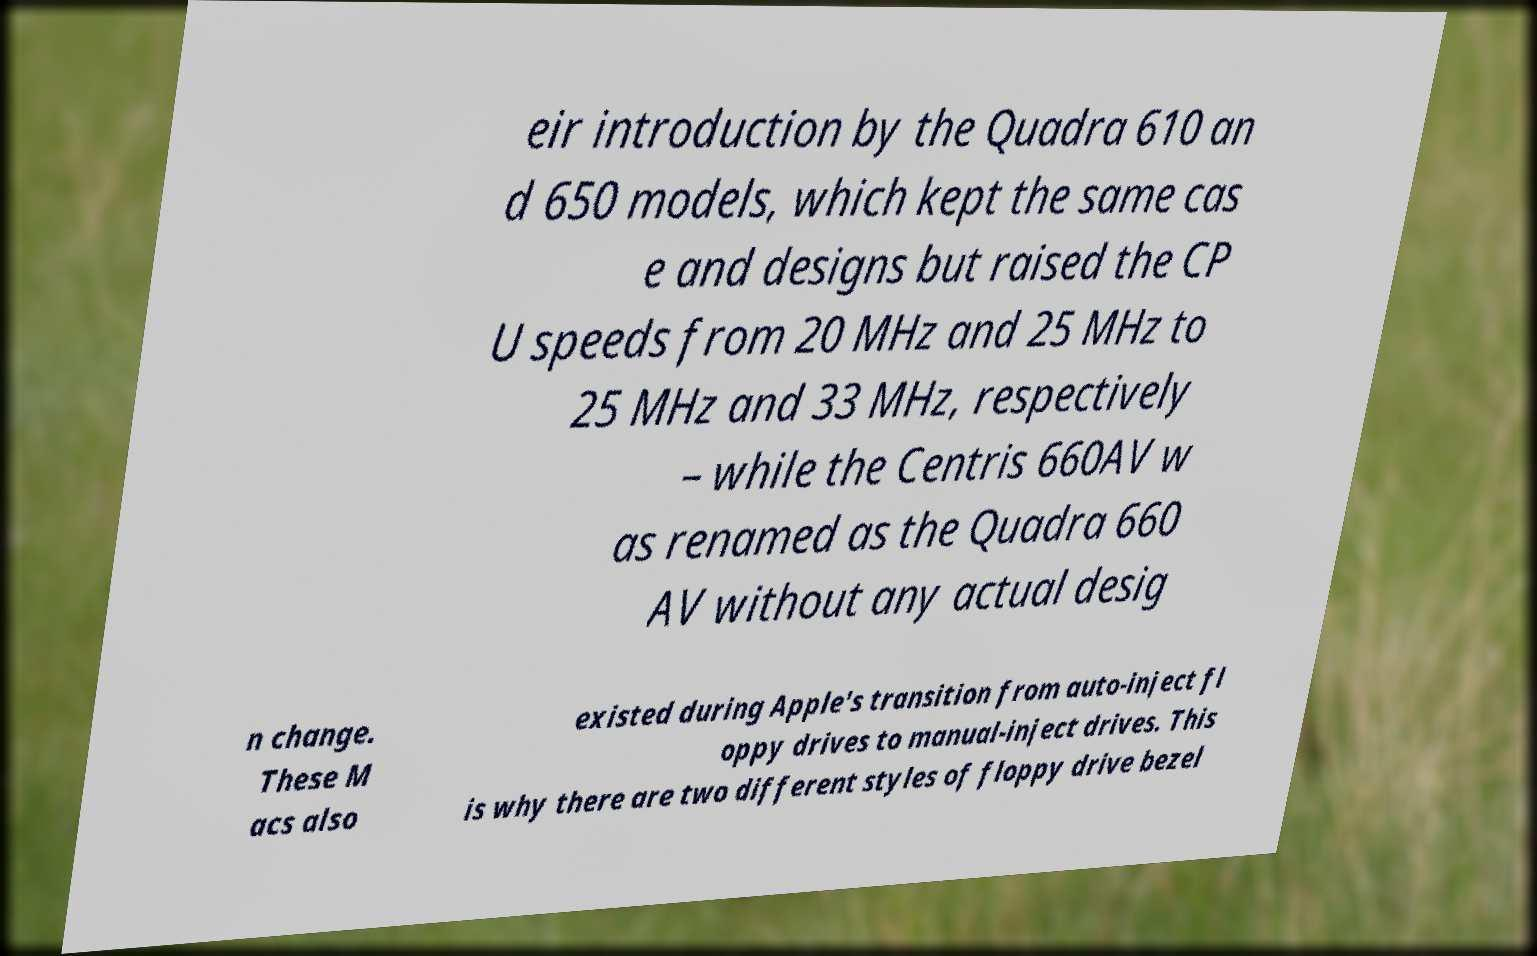What messages or text are displayed in this image? I need them in a readable, typed format. eir introduction by the Quadra 610 an d 650 models, which kept the same cas e and designs but raised the CP U speeds from 20 MHz and 25 MHz to 25 MHz and 33 MHz, respectively – while the Centris 660AV w as renamed as the Quadra 660 AV without any actual desig n change. These M acs also existed during Apple's transition from auto-inject fl oppy drives to manual-inject drives. This is why there are two different styles of floppy drive bezel 